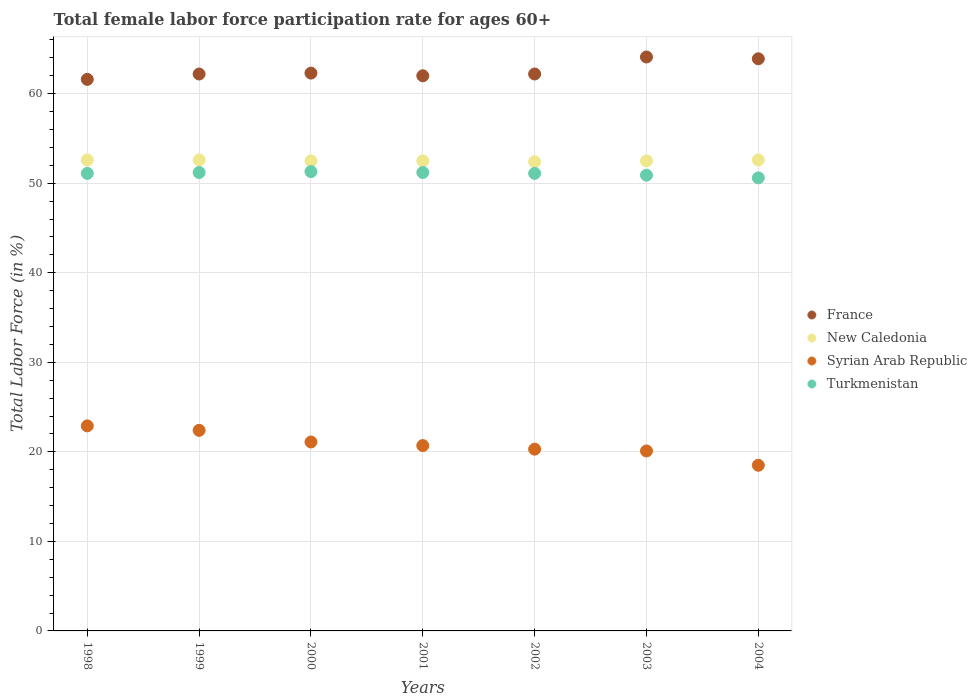How many different coloured dotlines are there?
Your response must be concise. 4. Is the number of dotlines equal to the number of legend labels?
Your response must be concise. Yes. What is the female labor force participation rate in New Caledonia in 2001?
Offer a very short reply. 52.5. Across all years, what is the maximum female labor force participation rate in Syrian Arab Republic?
Offer a very short reply. 22.9. Across all years, what is the minimum female labor force participation rate in New Caledonia?
Make the answer very short. 52.4. In which year was the female labor force participation rate in Turkmenistan maximum?
Ensure brevity in your answer.  2000. In which year was the female labor force participation rate in New Caledonia minimum?
Provide a succinct answer. 2002. What is the total female labor force participation rate in New Caledonia in the graph?
Ensure brevity in your answer.  367.7. What is the difference between the female labor force participation rate in France in 2001 and that in 2004?
Offer a terse response. -1.9. What is the difference between the female labor force participation rate in France in 1998 and the female labor force participation rate in Turkmenistan in 1999?
Your answer should be compact. 10.4. What is the average female labor force participation rate in Turkmenistan per year?
Offer a very short reply. 51.06. In the year 2001, what is the difference between the female labor force participation rate in New Caledonia and female labor force participation rate in Turkmenistan?
Ensure brevity in your answer.  1.3. In how many years, is the female labor force participation rate in Syrian Arab Republic greater than 48 %?
Ensure brevity in your answer.  0. What is the ratio of the female labor force participation rate in New Caledonia in 2000 to that in 2002?
Keep it short and to the point. 1. Is the female labor force participation rate in Turkmenistan in 2002 less than that in 2003?
Offer a very short reply. No. Is the difference between the female labor force participation rate in New Caledonia in 2000 and 2002 greater than the difference between the female labor force participation rate in Turkmenistan in 2000 and 2002?
Your response must be concise. No. What is the difference between the highest and the second highest female labor force participation rate in Syrian Arab Republic?
Keep it short and to the point. 0.5. What is the difference between the highest and the lowest female labor force participation rate in France?
Your response must be concise. 2.5. In how many years, is the female labor force participation rate in France greater than the average female labor force participation rate in France taken over all years?
Provide a succinct answer. 2. Is the sum of the female labor force participation rate in New Caledonia in 2002 and 2004 greater than the maximum female labor force participation rate in Syrian Arab Republic across all years?
Offer a terse response. Yes. Does the female labor force participation rate in Syrian Arab Republic monotonically increase over the years?
Offer a very short reply. No. Is the female labor force participation rate in Turkmenistan strictly less than the female labor force participation rate in Syrian Arab Republic over the years?
Keep it short and to the point. No. How many dotlines are there?
Make the answer very short. 4. How many years are there in the graph?
Your response must be concise. 7. What is the difference between two consecutive major ticks on the Y-axis?
Your answer should be compact. 10. Are the values on the major ticks of Y-axis written in scientific E-notation?
Your response must be concise. No. What is the title of the graph?
Give a very brief answer. Total female labor force participation rate for ages 60+. What is the label or title of the X-axis?
Provide a succinct answer. Years. What is the Total Labor Force (in %) of France in 1998?
Offer a terse response. 61.6. What is the Total Labor Force (in %) in New Caledonia in 1998?
Provide a short and direct response. 52.6. What is the Total Labor Force (in %) of Syrian Arab Republic in 1998?
Offer a terse response. 22.9. What is the Total Labor Force (in %) of Turkmenistan in 1998?
Provide a short and direct response. 51.1. What is the Total Labor Force (in %) of France in 1999?
Your response must be concise. 62.2. What is the Total Labor Force (in %) of New Caledonia in 1999?
Provide a succinct answer. 52.6. What is the Total Labor Force (in %) in Syrian Arab Republic in 1999?
Your answer should be very brief. 22.4. What is the Total Labor Force (in %) of Turkmenistan in 1999?
Your answer should be compact. 51.2. What is the Total Labor Force (in %) of France in 2000?
Your answer should be very brief. 62.3. What is the Total Labor Force (in %) of New Caledonia in 2000?
Provide a succinct answer. 52.5. What is the Total Labor Force (in %) in Syrian Arab Republic in 2000?
Provide a short and direct response. 21.1. What is the Total Labor Force (in %) in Turkmenistan in 2000?
Offer a terse response. 51.3. What is the Total Labor Force (in %) of New Caledonia in 2001?
Make the answer very short. 52.5. What is the Total Labor Force (in %) in Syrian Arab Republic in 2001?
Provide a succinct answer. 20.7. What is the Total Labor Force (in %) of Turkmenistan in 2001?
Offer a very short reply. 51.2. What is the Total Labor Force (in %) in France in 2002?
Provide a short and direct response. 62.2. What is the Total Labor Force (in %) of New Caledonia in 2002?
Provide a succinct answer. 52.4. What is the Total Labor Force (in %) in Syrian Arab Republic in 2002?
Your answer should be compact. 20.3. What is the Total Labor Force (in %) of Turkmenistan in 2002?
Provide a succinct answer. 51.1. What is the Total Labor Force (in %) in France in 2003?
Offer a terse response. 64.1. What is the Total Labor Force (in %) in New Caledonia in 2003?
Provide a short and direct response. 52.5. What is the Total Labor Force (in %) of Syrian Arab Republic in 2003?
Provide a succinct answer. 20.1. What is the Total Labor Force (in %) of Turkmenistan in 2003?
Offer a very short reply. 50.9. What is the Total Labor Force (in %) of France in 2004?
Keep it short and to the point. 63.9. What is the Total Labor Force (in %) of New Caledonia in 2004?
Offer a very short reply. 52.6. What is the Total Labor Force (in %) in Syrian Arab Republic in 2004?
Your answer should be compact. 18.5. What is the Total Labor Force (in %) in Turkmenistan in 2004?
Your answer should be compact. 50.6. Across all years, what is the maximum Total Labor Force (in %) in France?
Ensure brevity in your answer.  64.1. Across all years, what is the maximum Total Labor Force (in %) in New Caledonia?
Offer a terse response. 52.6. Across all years, what is the maximum Total Labor Force (in %) in Syrian Arab Republic?
Provide a succinct answer. 22.9. Across all years, what is the maximum Total Labor Force (in %) of Turkmenistan?
Keep it short and to the point. 51.3. Across all years, what is the minimum Total Labor Force (in %) of France?
Provide a short and direct response. 61.6. Across all years, what is the minimum Total Labor Force (in %) in New Caledonia?
Keep it short and to the point. 52.4. Across all years, what is the minimum Total Labor Force (in %) in Syrian Arab Republic?
Your answer should be compact. 18.5. Across all years, what is the minimum Total Labor Force (in %) in Turkmenistan?
Provide a succinct answer. 50.6. What is the total Total Labor Force (in %) in France in the graph?
Offer a very short reply. 438.3. What is the total Total Labor Force (in %) in New Caledonia in the graph?
Offer a terse response. 367.7. What is the total Total Labor Force (in %) of Syrian Arab Republic in the graph?
Offer a very short reply. 146. What is the total Total Labor Force (in %) in Turkmenistan in the graph?
Offer a very short reply. 357.4. What is the difference between the Total Labor Force (in %) in Syrian Arab Republic in 1998 and that in 1999?
Your answer should be very brief. 0.5. What is the difference between the Total Labor Force (in %) of Turkmenistan in 1998 and that in 1999?
Give a very brief answer. -0.1. What is the difference between the Total Labor Force (in %) of France in 1998 and that in 2000?
Give a very brief answer. -0.7. What is the difference between the Total Labor Force (in %) of New Caledonia in 1998 and that in 2000?
Your answer should be very brief. 0.1. What is the difference between the Total Labor Force (in %) of Syrian Arab Republic in 1998 and that in 2000?
Offer a terse response. 1.8. What is the difference between the Total Labor Force (in %) of Turkmenistan in 1998 and that in 2000?
Your response must be concise. -0.2. What is the difference between the Total Labor Force (in %) in New Caledonia in 1998 and that in 2001?
Offer a very short reply. 0.1. What is the difference between the Total Labor Force (in %) of New Caledonia in 1998 and that in 2002?
Your answer should be very brief. 0.2. What is the difference between the Total Labor Force (in %) of New Caledonia in 1998 and that in 2003?
Offer a terse response. 0.1. What is the difference between the Total Labor Force (in %) in Syrian Arab Republic in 1998 and that in 2003?
Provide a short and direct response. 2.8. What is the difference between the Total Labor Force (in %) in France in 1998 and that in 2004?
Give a very brief answer. -2.3. What is the difference between the Total Labor Force (in %) in Syrian Arab Republic in 1998 and that in 2004?
Your response must be concise. 4.4. What is the difference between the Total Labor Force (in %) of New Caledonia in 1999 and that in 2000?
Your response must be concise. 0.1. What is the difference between the Total Labor Force (in %) of New Caledonia in 1999 and that in 2001?
Offer a very short reply. 0.1. What is the difference between the Total Labor Force (in %) of France in 1999 and that in 2002?
Give a very brief answer. 0. What is the difference between the Total Labor Force (in %) in Turkmenistan in 1999 and that in 2002?
Your response must be concise. 0.1. What is the difference between the Total Labor Force (in %) of Syrian Arab Republic in 1999 and that in 2003?
Give a very brief answer. 2.3. What is the difference between the Total Labor Force (in %) in Turkmenistan in 1999 and that in 2003?
Ensure brevity in your answer.  0.3. What is the difference between the Total Labor Force (in %) in Syrian Arab Republic in 1999 and that in 2004?
Provide a short and direct response. 3.9. What is the difference between the Total Labor Force (in %) in Turkmenistan in 1999 and that in 2004?
Your response must be concise. 0.6. What is the difference between the Total Labor Force (in %) in New Caledonia in 2000 and that in 2001?
Provide a short and direct response. 0. What is the difference between the Total Labor Force (in %) in Turkmenistan in 2000 and that in 2001?
Offer a very short reply. 0.1. What is the difference between the Total Labor Force (in %) of France in 2000 and that in 2002?
Your answer should be compact. 0.1. What is the difference between the Total Labor Force (in %) of Syrian Arab Republic in 2000 and that in 2002?
Keep it short and to the point. 0.8. What is the difference between the Total Labor Force (in %) of Turkmenistan in 2000 and that in 2002?
Offer a very short reply. 0.2. What is the difference between the Total Labor Force (in %) in Syrian Arab Republic in 2000 and that in 2003?
Offer a very short reply. 1. What is the difference between the Total Labor Force (in %) in New Caledonia in 2000 and that in 2004?
Make the answer very short. -0.1. What is the difference between the Total Labor Force (in %) in Syrian Arab Republic in 2000 and that in 2004?
Ensure brevity in your answer.  2.6. What is the difference between the Total Labor Force (in %) in France in 2001 and that in 2002?
Offer a very short reply. -0.2. What is the difference between the Total Labor Force (in %) of New Caledonia in 2001 and that in 2002?
Provide a succinct answer. 0.1. What is the difference between the Total Labor Force (in %) of France in 2001 and that in 2003?
Offer a terse response. -2.1. What is the difference between the Total Labor Force (in %) of Syrian Arab Republic in 2001 and that in 2003?
Give a very brief answer. 0.6. What is the difference between the Total Labor Force (in %) of Turkmenistan in 2001 and that in 2003?
Ensure brevity in your answer.  0.3. What is the difference between the Total Labor Force (in %) in France in 2001 and that in 2004?
Keep it short and to the point. -1.9. What is the difference between the Total Labor Force (in %) in Syrian Arab Republic in 2001 and that in 2004?
Give a very brief answer. 2.2. What is the difference between the Total Labor Force (in %) of France in 2002 and that in 2003?
Offer a terse response. -1.9. What is the difference between the Total Labor Force (in %) of New Caledonia in 2002 and that in 2003?
Keep it short and to the point. -0.1. What is the difference between the Total Labor Force (in %) in Syrian Arab Republic in 2002 and that in 2003?
Offer a very short reply. 0.2. What is the difference between the Total Labor Force (in %) of Turkmenistan in 2002 and that in 2003?
Provide a succinct answer. 0.2. What is the difference between the Total Labor Force (in %) of France in 2002 and that in 2004?
Keep it short and to the point. -1.7. What is the difference between the Total Labor Force (in %) in New Caledonia in 2002 and that in 2004?
Provide a short and direct response. -0.2. What is the difference between the Total Labor Force (in %) in Syrian Arab Republic in 2002 and that in 2004?
Your response must be concise. 1.8. What is the difference between the Total Labor Force (in %) in Syrian Arab Republic in 2003 and that in 2004?
Provide a short and direct response. 1.6. What is the difference between the Total Labor Force (in %) in France in 1998 and the Total Labor Force (in %) in Syrian Arab Republic in 1999?
Offer a terse response. 39.2. What is the difference between the Total Labor Force (in %) of France in 1998 and the Total Labor Force (in %) of Turkmenistan in 1999?
Your answer should be very brief. 10.4. What is the difference between the Total Labor Force (in %) of New Caledonia in 1998 and the Total Labor Force (in %) of Syrian Arab Republic in 1999?
Your response must be concise. 30.2. What is the difference between the Total Labor Force (in %) in Syrian Arab Republic in 1998 and the Total Labor Force (in %) in Turkmenistan in 1999?
Provide a short and direct response. -28.3. What is the difference between the Total Labor Force (in %) of France in 1998 and the Total Labor Force (in %) of Syrian Arab Republic in 2000?
Offer a very short reply. 40.5. What is the difference between the Total Labor Force (in %) of France in 1998 and the Total Labor Force (in %) of Turkmenistan in 2000?
Offer a terse response. 10.3. What is the difference between the Total Labor Force (in %) of New Caledonia in 1998 and the Total Labor Force (in %) of Syrian Arab Republic in 2000?
Ensure brevity in your answer.  31.5. What is the difference between the Total Labor Force (in %) of Syrian Arab Republic in 1998 and the Total Labor Force (in %) of Turkmenistan in 2000?
Your answer should be compact. -28.4. What is the difference between the Total Labor Force (in %) of France in 1998 and the Total Labor Force (in %) of New Caledonia in 2001?
Give a very brief answer. 9.1. What is the difference between the Total Labor Force (in %) in France in 1998 and the Total Labor Force (in %) in Syrian Arab Republic in 2001?
Make the answer very short. 40.9. What is the difference between the Total Labor Force (in %) in New Caledonia in 1998 and the Total Labor Force (in %) in Syrian Arab Republic in 2001?
Give a very brief answer. 31.9. What is the difference between the Total Labor Force (in %) in New Caledonia in 1998 and the Total Labor Force (in %) in Turkmenistan in 2001?
Your response must be concise. 1.4. What is the difference between the Total Labor Force (in %) in Syrian Arab Republic in 1998 and the Total Labor Force (in %) in Turkmenistan in 2001?
Offer a very short reply. -28.3. What is the difference between the Total Labor Force (in %) of France in 1998 and the Total Labor Force (in %) of Syrian Arab Republic in 2002?
Offer a terse response. 41.3. What is the difference between the Total Labor Force (in %) in New Caledonia in 1998 and the Total Labor Force (in %) in Syrian Arab Republic in 2002?
Offer a very short reply. 32.3. What is the difference between the Total Labor Force (in %) in New Caledonia in 1998 and the Total Labor Force (in %) in Turkmenistan in 2002?
Provide a succinct answer. 1.5. What is the difference between the Total Labor Force (in %) in Syrian Arab Republic in 1998 and the Total Labor Force (in %) in Turkmenistan in 2002?
Give a very brief answer. -28.2. What is the difference between the Total Labor Force (in %) of France in 1998 and the Total Labor Force (in %) of New Caledonia in 2003?
Make the answer very short. 9.1. What is the difference between the Total Labor Force (in %) of France in 1998 and the Total Labor Force (in %) of Syrian Arab Republic in 2003?
Your response must be concise. 41.5. What is the difference between the Total Labor Force (in %) of France in 1998 and the Total Labor Force (in %) of Turkmenistan in 2003?
Your answer should be very brief. 10.7. What is the difference between the Total Labor Force (in %) in New Caledonia in 1998 and the Total Labor Force (in %) in Syrian Arab Republic in 2003?
Ensure brevity in your answer.  32.5. What is the difference between the Total Labor Force (in %) in France in 1998 and the Total Labor Force (in %) in New Caledonia in 2004?
Your answer should be very brief. 9. What is the difference between the Total Labor Force (in %) of France in 1998 and the Total Labor Force (in %) of Syrian Arab Republic in 2004?
Your response must be concise. 43.1. What is the difference between the Total Labor Force (in %) of France in 1998 and the Total Labor Force (in %) of Turkmenistan in 2004?
Keep it short and to the point. 11. What is the difference between the Total Labor Force (in %) of New Caledonia in 1998 and the Total Labor Force (in %) of Syrian Arab Republic in 2004?
Offer a very short reply. 34.1. What is the difference between the Total Labor Force (in %) of Syrian Arab Republic in 1998 and the Total Labor Force (in %) of Turkmenistan in 2004?
Offer a terse response. -27.7. What is the difference between the Total Labor Force (in %) of France in 1999 and the Total Labor Force (in %) of Syrian Arab Republic in 2000?
Your answer should be very brief. 41.1. What is the difference between the Total Labor Force (in %) in New Caledonia in 1999 and the Total Labor Force (in %) in Syrian Arab Republic in 2000?
Your answer should be very brief. 31.5. What is the difference between the Total Labor Force (in %) in New Caledonia in 1999 and the Total Labor Force (in %) in Turkmenistan in 2000?
Your response must be concise. 1.3. What is the difference between the Total Labor Force (in %) in Syrian Arab Republic in 1999 and the Total Labor Force (in %) in Turkmenistan in 2000?
Your answer should be very brief. -28.9. What is the difference between the Total Labor Force (in %) of France in 1999 and the Total Labor Force (in %) of New Caledonia in 2001?
Offer a very short reply. 9.7. What is the difference between the Total Labor Force (in %) in France in 1999 and the Total Labor Force (in %) in Syrian Arab Republic in 2001?
Ensure brevity in your answer.  41.5. What is the difference between the Total Labor Force (in %) of New Caledonia in 1999 and the Total Labor Force (in %) of Syrian Arab Republic in 2001?
Your response must be concise. 31.9. What is the difference between the Total Labor Force (in %) of Syrian Arab Republic in 1999 and the Total Labor Force (in %) of Turkmenistan in 2001?
Ensure brevity in your answer.  -28.8. What is the difference between the Total Labor Force (in %) in France in 1999 and the Total Labor Force (in %) in New Caledonia in 2002?
Give a very brief answer. 9.8. What is the difference between the Total Labor Force (in %) of France in 1999 and the Total Labor Force (in %) of Syrian Arab Republic in 2002?
Your response must be concise. 41.9. What is the difference between the Total Labor Force (in %) of France in 1999 and the Total Labor Force (in %) of Turkmenistan in 2002?
Give a very brief answer. 11.1. What is the difference between the Total Labor Force (in %) in New Caledonia in 1999 and the Total Labor Force (in %) in Syrian Arab Republic in 2002?
Offer a terse response. 32.3. What is the difference between the Total Labor Force (in %) of New Caledonia in 1999 and the Total Labor Force (in %) of Turkmenistan in 2002?
Your answer should be very brief. 1.5. What is the difference between the Total Labor Force (in %) in Syrian Arab Republic in 1999 and the Total Labor Force (in %) in Turkmenistan in 2002?
Offer a terse response. -28.7. What is the difference between the Total Labor Force (in %) in France in 1999 and the Total Labor Force (in %) in New Caledonia in 2003?
Make the answer very short. 9.7. What is the difference between the Total Labor Force (in %) in France in 1999 and the Total Labor Force (in %) in Syrian Arab Republic in 2003?
Offer a very short reply. 42.1. What is the difference between the Total Labor Force (in %) of New Caledonia in 1999 and the Total Labor Force (in %) of Syrian Arab Republic in 2003?
Make the answer very short. 32.5. What is the difference between the Total Labor Force (in %) in New Caledonia in 1999 and the Total Labor Force (in %) in Turkmenistan in 2003?
Your response must be concise. 1.7. What is the difference between the Total Labor Force (in %) in Syrian Arab Republic in 1999 and the Total Labor Force (in %) in Turkmenistan in 2003?
Give a very brief answer. -28.5. What is the difference between the Total Labor Force (in %) in France in 1999 and the Total Labor Force (in %) in New Caledonia in 2004?
Provide a succinct answer. 9.6. What is the difference between the Total Labor Force (in %) of France in 1999 and the Total Labor Force (in %) of Syrian Arab Republic in 2004?
Make the answer very short. 43.7. What is the difference between the Total Labor Force (in %) in France in 1999 and the Total Labor Force (in %) in Turkmenistan in 2004?
Ensure brevity in your answer.  11.6. What is the difference between the Total Labor Force (in %) in New Caledonia in 1999 and the Total Labor Force (in %) in Syrian Arab Republic in 2004?
Your answer should be compact. 34.1. What is the difference between the Total Labor Force (in %) in Syrian Arab Republic in 1999 and the Total Labor Force (in %) in Turkmenistan in 2004?
Ensure brevity in your answer.  -28.2. What is the difference between the Total Labor Force (in %) of France in 2000 and the Total Labor Force (in %) of Syrian Arab Republic in 2001?
Your answer should be very brief. 41.6. What is the difference between the Total Labor Force (in %) of New Caledonia in 2000 and the Total Labor Force (in %) of Syrian Arab Republic in 2001?
Offer a terse response. 31.8. What is the difference between the Total Labor Force (in %) of New Caledonia in 2000 and the Total Labor Force (in %) of Turkmenistan in 2001?
Offer a very short reply. 1.3. What is the difference between the Total Labor Force (in %) of Syrian Arab Republic in 2000 and the Total Labor Force (in %) of Turkmenistan in 2001?
Provide a succinct answer. -30.1. What is the difference between the Total Labor Force (in %) in New Caledonia in 2000 and the Total Labor Force (in %) in Syrian Arab Republic in 2002?
Give a very brief answer. 32.2. What is the difference between the Total Labor Force (in %) of New Caledonia in 2000 and the Total Labor Force (in %) of Turkmenistan in 2002?
Offer a terse response. 1.4. What is the difference between the Total Labor Force (in %) in France in 2000 and the Total Labor Force (in %) in Syrian Arab Republic in 2003?
Ensure brevity in your answer.  42.2. What is the difference between the Total Labor Force (in %) in New Caledonia in 2000 and the Total Labor Force (in %) in Syrian Arab Republic in 2003?
Offer a very short reply. 32.4. What is the difference between the Total Labor Force (in %) of Syrian Arab Republic in 2000 and the Total Labor Force (in %) of Turkmenistan in 2003?
Offer a very short reply. -29.8. What is the difference between the Total Labor Force (in %) in France in 2000 and the Total Labor Force (in %) in Syrian Arab Republic in 2004?
Keep it short and to the point. 43.8. What is the difference between the Total Labor Force (in %) in New Caledonia in 2000 and the Total Labor Force (in %) in Syrian Arab Republic in 2004?
Your answer should be compact. 34. What is the difference between the Total Labor Force (in %) in Syrian Arab Republic in 2000 and the Total Labor Force (in %) in Turkmenistan in 2004?
Make the answer very short. -29.5. What is the difference between the Total Labor Force (in %) of France in 2001 and the Total Labor Force (in %) of Syrian Arab Republic in 2002?
Offer a terse response. 41.7. What is the difference between the Total Labor Force (in %) in France in 2001 and the Total Labor Force (in %) in Turkmenistan in 2002?
Ensure brevity in your answer.  10.9. What is the difference between the Total Labor Force (in %) of New Caledonia in 2001 and the Total Labor Force (in %) of Syrian Arab Republic in 2002?
Your response must be concise. 32.2. What is the difference between the Total Labor Force (in %) of Syrian Arab Republic in 2001 and the Total Labor Force (in %) of Turkmenistan in 2002?
Make the answer very short. -30.4. What is the difference between the Total Labor Force (in %) of France in 2001 and the Total Labor Force (in %) of Syrian Arab Republic in 2003?
Make the answer very short. 41.9. What is the difference between the Total Labor Force (in %) in New Caledonia in 2001 and the Total Labor Force (in %) in Syrian Arab Republic in 2003?
Offer a very short reply. 32.4. What is the difference between the Total Labor Force (in %) in Syrian Arab Republic in 2001 and the Total Labor Force (in %) in Turkmenistan in 2003?
Make the answer very short. -30.2. What is the difference between the Total Labor Force (in %) of France in 2001 and the Total Labor Force (in %) of Syrian Arab Republic in 2004?
Give a very brief answer. 43.5. What is the difference between the Total Labor Force (in %) in New Caledonia in 2001 and the Total Labor Force (in %) in Syrian Arab Republic in 2004?
Make the answer very short. 34. What is the difference between the Total Labor Force (in %) of New Caledonia in 2001 and the Total Labor Force (in %) of Turkmenistan in 2004?
Offer a very short reply. 1.9. What is the difference between the Total Labor Force (in %) of Syrian Arab Republic in 2001 and the Total Labor Force (in %) of Turkmenistan in 2004?
Provide a short and direct response. -29.9. What is the difference between the Total Labor Force (in %) in France in 2002 and the Total Labor Force (in %) in New Caledonia in 2003?
Give a very brief answer. 9.7. What is the difference between the Total Labor Force (in %) in France in 2002 and the Total Labor Force (in %) in Syrian Arab Republic in 2003?
Provide a succinct answer. 42.1. What is the difference between the Total Labor Force (in %) of New Caledonia in 2002 and the Total Labor Force (in %) of Syrian Arab Republic in 2003?
Your answer should be compact. 32.3. What is the difference between the Total Labor Force (in %) of New Caledonia in 2002 and the Total Labor Force (in %) of Turkmenistan in 2003?
Offer a terse response. 1.5. What is the difference between the Total Labor Force (in %) of Syrian Arab Republic in 2002 and the Total Labor Force (in %) of Turkmenistan in 2003?
Offer a very short reply. -30.6. What is the difference between the Total Labor Force (in %) of France in 2002 and the Total Labor Force (in %) of Syrian Arab Republic in 2004?
Your answer should be compact. 43.7. What is the difference between the Total Labor Force (in %) of France in 2002 and the Total Labor Force (in %) of Turkmenistan in 2004?
Your answer should be compact. 11.6. What is the difference between the Total Labor Force (in %) of New Caledonia in 2002 and the Total Labor Force (in %) of Syrian Arab Republic in 2004?
Ensure brevity in your answer.  33.9. What is the difference between the Total Labor Force (in %) of Syrian Arab Republic in 2002 and the Total Labor Force (in %) of Turkmenistan in 2004?
Offer a terse response. -30.3. What is the difference between the Total Labor Force (in %) of France in 2003 and the Total Labor Force (in %) of Syrian Arab Republic in 2004?
Provide a succinct answer. 45.6. What is the difference between the Total Labor Force (in %) of France in 2003 and the Total Labor Force (in %) of Turkmenistan in 2004?
Make the answer very short. 13.5. What is the difference between the Total Labor Force (in %) of New Caledonia in 2003 and the Total Labor Force (in %) of Turkmenistan in 2004?
Give a very brief answer. 1.9. What is the difference between the Total Labor Force (in %) in Syrian Arab Republic in 2003 and the Total Labor Force (in %) in Turkmenistan in 2004?
Provide a succinct answer. -30.5. What is the average Total Labor Force (in %) of France per year?
Your response must be concise. 62.61. What is the average Total Labor Force (in %) of New Caledonia per year?
Offer a terse response. 52.53. What is the average Total Labor Force (in %) of Syrian Arab Republic per year?
Provide a succinct answer. 20.86. What is the average Total Labor Force (in %) in Turkmenistan per year?
Provide a short and direct response. 51.06. In the year 1998, what is the difference between the Total Labor Force (in %) in France and Total Labor Force (in %) in New Caledonia?
Offer a very short reply. 9. In the year 1998, what is the difference between the Total Labor Force (in %) in France and Total Labor Force (in %) in Syrian Arab Republic?
Provide a succinct answer. 38.7. In the year 1998, what is the difference between the Total Labor Force (in %) in France and Total Labor Force (in %) in Turkmenistan?
Offer a very short reply. 10.5. In the year 1998, what is the difference between the Total Labor Force (in %) in New Caledonia and Total Labor Force (in %) in Syrian Arab Republic?
Make the answer very short. 29.7. In the year 1998, what is the difference between the Total Labor Force (in %) of Syrian Arab Republic and Total Labor Force (in %) of Turkmenistan?
Keep it short and to the point. -28.2. In the year 1999, what is the difference between the Total Labor Force (in %) of France and Total Labor Force (in %) of New Caledonia?
Ensure brevity in your answer.  9.6. In the year 1999, what is the difference between the Total Labor Force (in %) in France and Total Labor Force (in %) in Syrian Arab Republic?
Your response must be concise. 39.8. In the year 1999, what is the difference between the Total Labor Force (in %) of France and Total Labor Force (in %) of Turkmenistan?
Your answer should be compact. 11. In the year 1999, what is the difference between the Total Labor Force (in %) in New Caledonia and Total Labor Force (in %) in Syrian Arab Republic?
Provide a short and direct response. 30.2. In the year 1999, what is the difference between the Total Labor Force (in %) in New Caledonia and Total Labor Force (in %) in Turkmenistan?
Your response must be concise. 1.4. In the year 1999, what is the difference between the Total Labor Force (in %) of Syrian Arab Republic and Total Labor Force (in %) of Turkmenistan?
Provide a succinct answer. -28.8. In the year 2000, what is the difference between the Total Labor Force (in %) in France and Total Labor Force (in %) in New Caledonia?
Provide a short and direct response. 9.8. In the year 2000, what is the difference between the Total Labor Force (in %) in France and Total Labor Force (in %) in Syrian Arab Republic?
Keep it short and to the point. 41.2. In the year 2000, what is the difference between the Total Labor Force (in %) of France and Total Labor Force (in %) of Turkmenistan?
Make the answer very short. 11. In the year 2000, what is the difference between the Total Labor Force (in %) of New Caledonia and Total Labor Force (in %) of Syrian Arab Republic?
Make the answer very short. 31.4. In the year 2000, what is the difference between the Total Labor Force (in %) of Syrian Arab Republic and Total Labor Force (in %) of Turkmenistan?
Give a very brief answer. -30.2. In the year 2001, what is the difference between the Total Labor Force (in %) in France and Total Labor Force (in %) in New Caledonia?
Provide a short and direct response. 9.5. In the year 2001, what is the difference between the Total Labor Force (in %) of France and Total Labor Force (in %) of Syrian Arab Republic?
Offer a very short reply. 41.3. In the year 2001, what is the difference between the Total Labor Force (in %) in France and Total Labor Force (in %) in Turkmenistan?
Offer a terse response. 10.8. In the year 2001, what is the difference between the Total Labor Force (in %) of New Caledonia and Total Labor Force (in %) of Syrian Arab Republic?
Ensure brevity in your answer.  31.8. In the year 2001, what is the difference between the Total Labor Force (in %) in New Caledonia and Total Labor Force (in %) in Turkmenistan?
Your response must be concise. 1.3. In the year 2001, what is the difference between the Total Labor Force (in %) in Syrian Arab Republic and Total Labor Force (in %) in Turkmenistan?
Make the answer very short. -30.5. In the year 2002, what is the difference between the Total Labor Force (in %) of France and Total Labor Force (in %) of Syrian Arab Republic?
Offer a terse response. 41.9. In the year 2002, what is the difference between the Total Labor Force (in %) in France and Total Labor Force (in %) in Turkmenistan?
Provide a short and direct response. 11.1. In the year 2002, what is the difference between the Total Labor Force (in %) of New Caledonia and Total Labor Force (in %) of Syrian Arab Republic?
Your answer should be compact. 32.1. In the year 2002, what is the difference between the Total Labor Force (in %) in New Caledonia and Total Labor Force (in %) in Turkmenistan?
Offer a terse response. 1.3. In the year 2002, what is the difference between the Total Labor Force (in %) of Syrian Arab Republic and Total Labor Force (in %) of Turkmenistan?
Offer a terse response. -30.8. In the year 2003, what is the difference between the Total Labor Force (in %) of France and Total Labor Force (in %) of New Caledonia?
Your response must be concise. 11.6. In the year 2003, what is the difference between the Total Labor Force (in %) in France and Total Labor Force (in %) in Syrian Arab Republic?
Provide a succinct answer. 44. In the year 2003, what is the difference between the Total Labor Force (in %) in France and Total Labor Force (in %) in Turkmenistan?
Ensure brevity in your answer.  13.2. In the year 2003, what is the difference between the Total Labor Force (in %) in New Caledonia and Total Labor Force (in %) in Syrian Arab Republic?
Your answer should be very brief. 32.4. In the year 2003, what is the difference between the Total Labor Force (in %) of Syrian Arab Republic and Total Labor Force (in %) of Turkmenistan?
Offer a very short reply. -30.8. In the year 2004, what is the difference between the Total Labor Force (in %) in France and Total Labor Force (in %) in Syrian Arab Republic?
Your response must be concise. 45.4. In the year 2004, what is the difference between the Total Labor Force (in %) of New Caledonia and Total Labor Force (in %) of Syrian Arab Republic?
Ensure brevity in your answer.  34.1. In the year 2004, what is the difference between the Total Labor Force (in %) in New Caledonia and Total Labor Force (in %) in Turkmenistan?
Your response must be concise. 2. In the year 2004, what is the difference between the Total Labor Force (in %) of Syrian Arab Republic and Total Labor Force (in %) of Turkmenistan?
Give a very brief answer. -32.1. What is the ratio of the Total Labor Force (in %) of New Caledonia in 1998 to that in 1999?
Give a very brief answer. 1. What is the ratio of the Total Labor Force (in %) in Syrian Arab Republic in 1998 to that in 1999?
Keep it short and to the point. 1.02. What is the ratio of the Total Labor Force (in %) of France in 1998 to that in 2000?
Keep it short and to the point. 0.99. What is the ratio of the Total Labor Force (in %) of Syrian Arab Republic in 1998 to that in 2000?
Provide a succinct answer. 1.09. What is the ratio of the Total Labor Force (in %) of France in 1998 to that in 2001?
Your answer should be very brief. 0.99. What is the ratio of the Total Labor Force (in %) in New Caledonia in 1998 to that in 2001?
Provide a succinct answer. 1. What is the ratio of the Total Labor Force (in %) in Syrian Arab Republic in 1998 to that in 2001?
Provide a short and direct response. 1.11. What is the ratio of the Total Labor Force (in %) of Syrian Arab Republic in 1998 to that in 2002?
Offer a very short reply. 1.13. What is the ratio of the Total Labor Force (in %) of Turkmenistan in 1998 to that in 2002?
Ensure brevity in your answer.  1. What is the ratio of the Total Labor Force (in %) in Syrian Arab Republic in 1998 to that in 2003?
Your answer should be very brief. 1.14. What is the ratio of the Total Labor Force (in %) of Turkmenistan in 1998 to that in 2003?
Provide a short and direct response. 1. What is the ratio of the Total Labor Force (in %) of France in 1998 to that in 2004?
Offer a very short reply. 0.96. What is the ratio of the Total Labor Force (in %) in Syrian Arab Republic in 1998 to that in 2004?
Your answer should be compact. 1.24. What is the ratio of the Total Labor Force (in %) of Turkmenistan in 1998 to that in 2004?
Provide a succinct answer. 1.01. What is the ratio of the Total Labor Force (in %) of Syrian Arab Republic in 1999 to that in 2000?
Give a very brief answer. 1.06. What is the ratio of the Total Labor Force (in %) of Turkmenistan in 1999 to that in 2000?
Keep it short and to the point. 1. What is the ratio of the Total Labor Force (in %) in Syrian Arab Republic in 1999 to that in 2001?
Give a very brief answer. 1.08. What is the ratio of the Total Labor Force (in %) of France in 1999 to that in 2002?
Your answer should be very brief. 1. What is the ratio of the Total Labor Force (in %) in New Caledonia in 1999 to that in 2002?
Offer a very short reply. 1. What is the ratio of the Total Labor Force (in %) in Syrian Arab Republic in 1999 to that in 2002?
Ensure brevity in your answer.  1.1. What is the ratio of the Total Labor Force (in %) in Turkmenistan in 1999 to that in 2002?
Your answer should be compact. 1. What is the ratio of the Total Labor Force (in %) of France in 1999 to that in 2003?
Ensure brevity in your answer.  0.97. What is the ratio of the Total Labor Force (in %) of New Caledonia in 1999 to that in 2003?
Your response must be concise. 1. What is the ratio of the Total Labor Force (in %) in Syrian Arab Republic in 1999 to that in 2003?
Make the answer very short. 1.11. What is the ratio of the Total Labor Force (in %) of Turkmenistan in 1999 to that in 2003?
Provide a succinct answer. 1.01. What is the ratio of the Total Labor Force (in %) in France in 1999 to that in 2004?
Keep it short and to the point. 0.97. What is the ratio of the Total Labor Force (in %) in New Caledonia in 1999 to that in 2004?
Offer a very short reply. 1. What is the ratio of the Total Labor Force (in %) in Syrian Arab Republic in 1999 to that in 2004?
Keep it short and to the point. 1.21. What is the ratio of the Total Labor Force (in %) of Turkmenistan in 1999 to that in 2004?
Make the answer very short. 1.01. What is the ratio of the Total Labor Force (in %) in France in 2000 to that in 2001?
Ensure brevity in your answer.  1. What is the ratio of the Total Labor Force (in %) in New Caledonia in 2000 to that in 2001?
Provide a succinct answer. 1. What is the ratio of the Total Labor Force (in %) in Syrian Arab Republic in 2000 to that in 2001?
Provide a succinct answer. 1.02. What is the ratio of the Total Labor Force (in %) in Turkmenistan in 2000 to that in 2001?
Provide a short and direct response. 1. What is the ratio of the Total Labor Force (in %) of France in 2000 to that in 2002?
Offer a terse response. 1. What is the ratio of the Total Labor Force (in %) of New Caledonia in 2000 to that in 2002?
Make the answer very short. 1. What is the ratio of the Total Labor Force (in %) in Syrian Arab Republic in 2000 to that in 2002?
Offer a terse response. 1.04. What is the ratio of the Total Labor Force (in %) of France in 2000 to that in 2003?
Your response must be concise. 0.97. What is the ratio of the Total Labor Force (in %) in New Caledonia in 2000 to that in 2003?
Keep it short and to the point. 1. What is the ratio of the Total Labor Force (in %) in Syrian Arab Republic in 2000 to that in 2003?
Your response must be concise. 1.05. What is the ratio of the Total Labor Force (in %) of Turkmenistan in 2000 to that in 2003?
Offer a terse response. 1.01. What is the ratio of the Total Labor Force (in %) of France in 2000 to that in 2004?
Your response must be concise. 0.97. What is the ratio of the Total Labor Force (in %) in Syrian Arab Republic in 2000 to that in 2004?
Offer a very short reply. 1.14. What is the ratio of the Total Labor Force (in %) of Turkmenistan in 2000 to that in 2004?
Keep it short and to the point. 1.01. What is the ratio of the Total Labor Force (in %) of France in 2001 to that in 2002?
Offer a terse response. 1. What is the ratio of the Total Labor Force (in %) of New Caledonia in 2001 to that in 2002?
Make the answer very short. 1. What is the ratio of the Total Labor Force (in %) in Syrian Arab Republic in 2001 to that in 2002?
Your answer should be very brief. 1.02. What is the ratio of the Total Labor Force (in %) in Turkmenistan in 2001 to that in 2002?
Ensure brevity in your answer.  1. What is the ratio of the Total Labor Force (in %) of France in 2001 to that in 2003?
Your answer should be compact. 0.97. What is the ratio of the Total Labor Force (in %) of Syrian Arab Republic in 2001 to that in 2003?
Provide a short and direct response. 1.03. What is the ratio of the Total Labor Force (in %) in Turkmenistan in 2001 to that in 2003?
Provide a short and direct response. 1.01. What is the ratio of the Total Labor Force (in %) of France in 2001 to that in 2004?
Make the answer very short. 0.97. What is the ratio of the Total Labor Force (in %) of Syrian Arab Republic in 2001 to that in 2004?
Provide a succinct answer. 1.12. What is the ratio of the Total Labor Force (in %) in Turkmenistan in 2001 to that in 2004?
Offer a very short reply. 1.01. What is the ratio of the Total Labor Force (in %) in France in 2002 to that in 2003?
Provide a succinct answer. 0.97. What is the ratio of the Total Labor Force (in %) in New Caledonia in 2002 to that in 2003?
Your answer should be compact. 1. What is the ratio of the Total Labor Force (in %) of Syrian Arab Republic in 2002 to that in 2003?
Your response must be concise. 1.01. What is the ratio of the Total Labor Force (in %) in France in 2002 to that in 2004?
Make the answer very short. 0.97. What is the ratio of the Total Labor Force (in %) of Syrian Arab Republic in 2002 to that in 2004?
Your response must be concise. 1.1. What is the ratio of the Total Labor Force (in %) of Turkmenistan in 2002 to that in 2004?
Provide a succinct answer. 1.01. What is the ratio of the Total Labor Force (in %) of France in 2003 to that in 2004?
Make the answer very short. 1. What is the ratio of the Total Labor Force (in %) of New Caledonia in 2003 to that in 2004?
Your answer should be very brief. 1. What is the ratio of the Total Labor Force (in %) in Syrian Arab Republic in 2003 to that in 2004?
Offer a terse response. 1.09. What is the ratio of the Total Labor Force (in %) in Turkmenistan in 2003 to that in 2004?
Offer a very short reply. 1.01. What is the difference between the highest and the second highest Total Labor Force (in %) of Turkmenistan?
Offer a very short reply. 0.1. What is the difference between the highest and the lowest Total Labor Force (in %) of France?
Provide a short and direct response. 2.5. What is the difference between the highest and the lowest Total Labor Force (in %) in Syrian Arab Republic?
Ensure brevity in your answer.  4.4. What is the difference between the highest and the lowest Total Labor Force (in %) of Turkmenistan?
Provide a short and direct response. 0.7. 